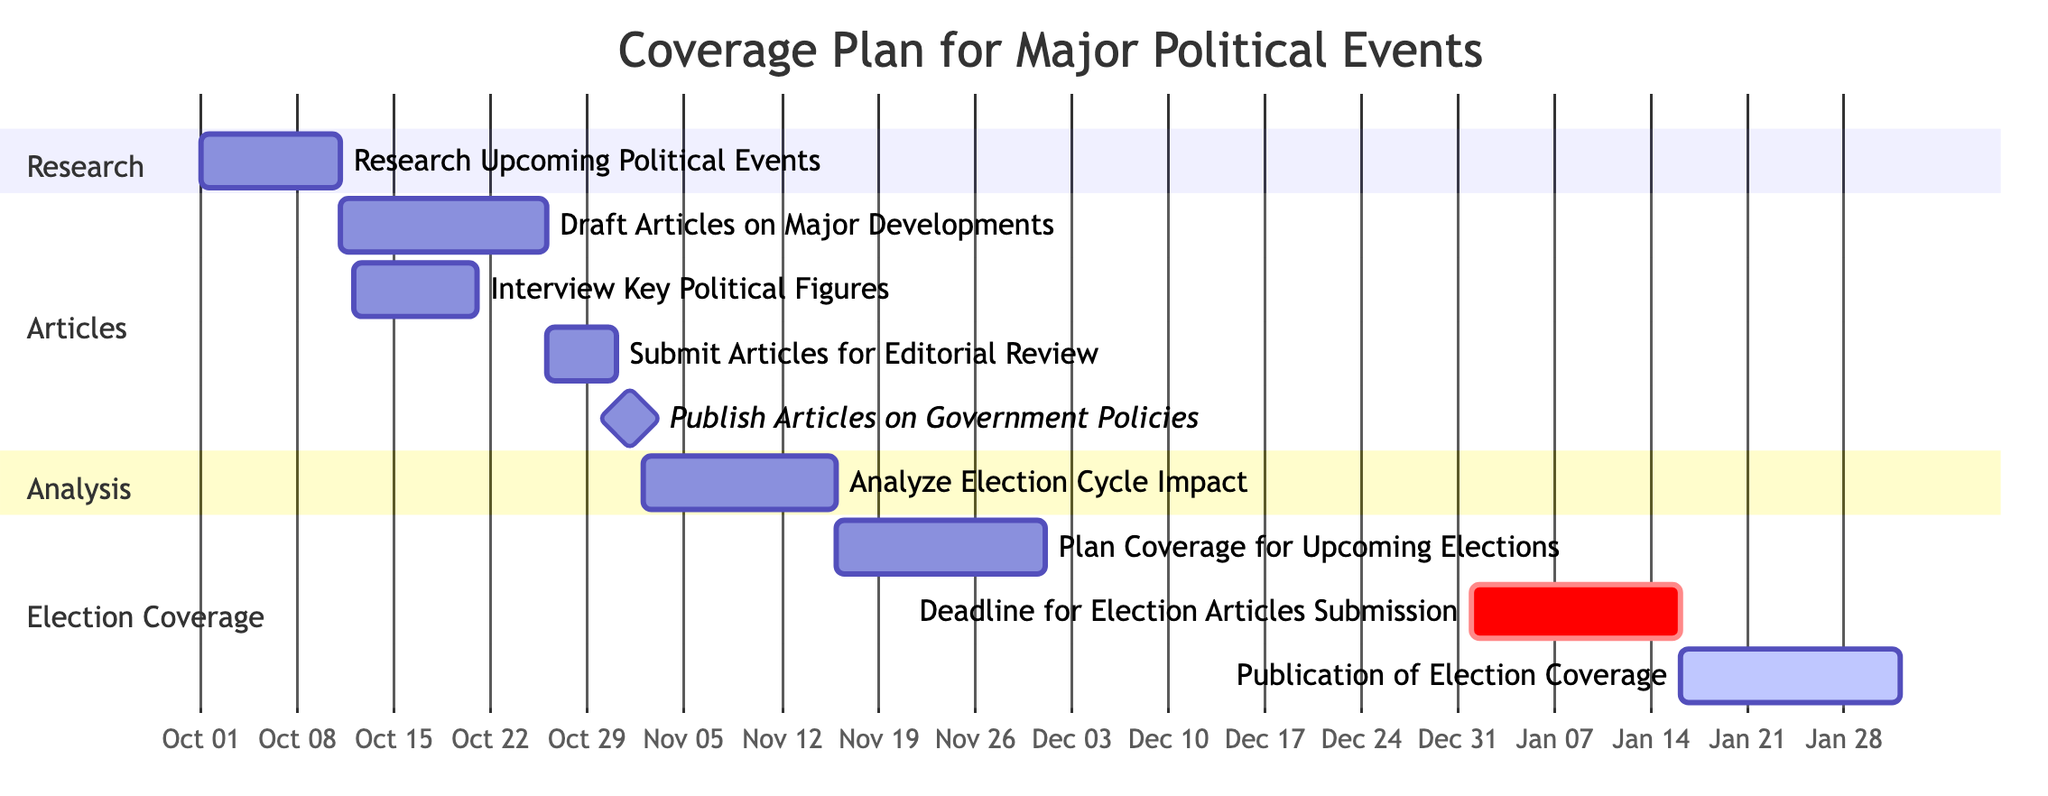What is the duration of the task "Research Upcoming Political Events"? The task "Research Upcoming Political Events" starts on October 1, 2023, and ends on October 10, 2023. To find the duration, count the days between these two dates, which is 10 days.
Answer: 10 days What task overlaps with "Draft Articles on Major Developments"? "Draft Articles on Major Developments" starts on October 11, 2023, and ends on October 25, 2023, while "Interview Key Political Figures" starts on October 12, 2023, and ends on October 20, 2023. Both tasks share the period from October 12 to October 20, thus they overlap.
Answer: Interview Key Political Figures When is the deadline for submitting articles for editorial review? The task "Submit Articles for Editorial Review" spans from October 26 to October 30, 2023, and has a specified deadline listed as October 30, 2023.
Answer: October 30, 2023 Which task is scheduled as a milestone? A milestone is a significant point in the schedule, and here, "Publish Articles on Government Policies" is marked as a milestone occurring on November 1, 2023.
Answer: Publish Articles on Government Policies How many days are allocated for the task "Analyze Election Cycle Impact"? The task "Analyze Election Cycle Impact" starts on November 2, 2023, and ends on November 15, 2023. Counting the days gives us a total of 14 days allotted for this task.
Answer: 14 days What is the start date for "Publication of Election Coverage"? The task "Publication of Election Coverage" begins on January 16, 2024, as indicated in the diagram, and runs until January 31, 2024.
Answer: January 16, 2024 What task is critical and has a deadline of January 15, 2024? The task designated with a critical status and that has a deadline of January 15, 2024, is "Deadline for Election Articles Submission". This indicates its importance in the schedule.
Answer: Deadline for Election Articles Submission What is the total number of tasks illustrated in the diagram? By examining the diagram, we can count each distinct task listed: there are a total of 8 tasks outlined within the provided coverage plan.
Answer: 8 tasks 